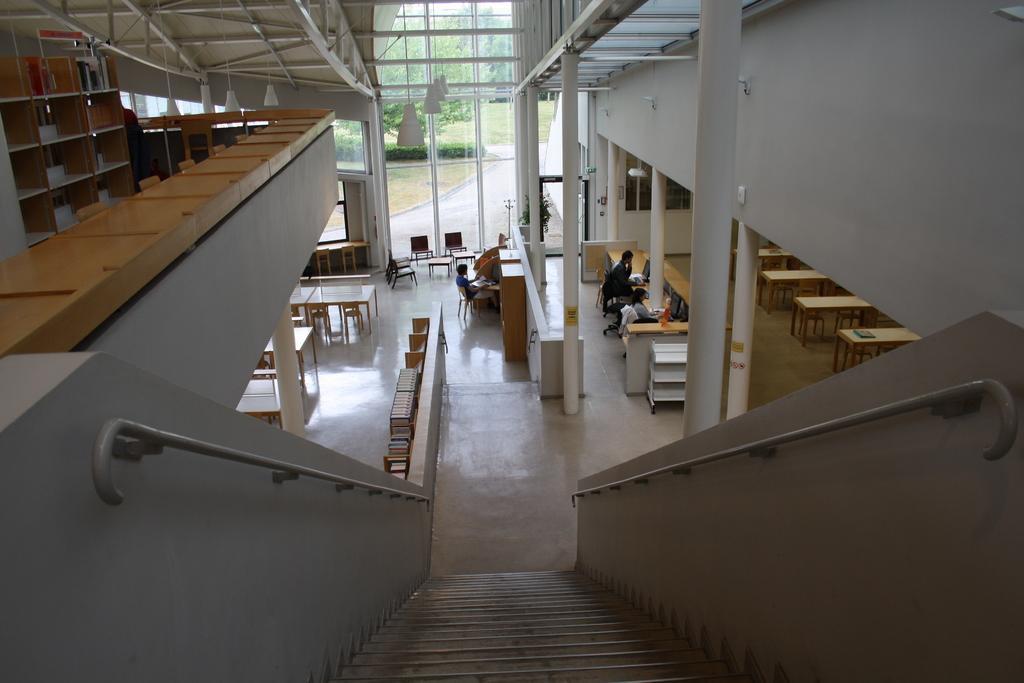How would you summarize this image in a sentence or two? In this picture I can observe stairs in the bottom of the picture. On either sides of the stairs I can observe bars fixed to the wall. On the left side I can observe racks. In the middle of the picture I can observe people sitting on the chairs in front of the desks. In the background I can observe trees. 